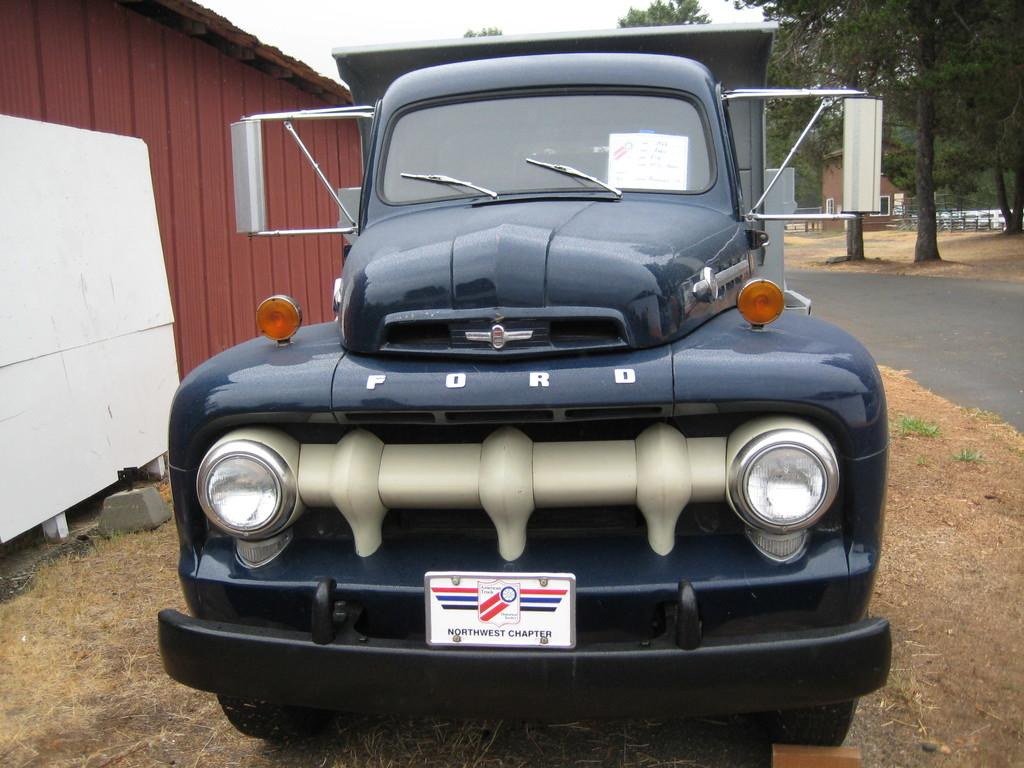What is the main subject of the image? There is a vehicle in the image. Can you describe the color of the vehicle? The vehicle is blue. What can be seen in the background of the image? There is a shed and trees in the background of the image. What is the color of the trees in the image? The trees are green. How would you describe the sky in the image? The sky is white in the image. How many tails can be seen on the vehicle in the image? There are no tails visible on the vehicle in the image. In which direction is the vehicle facing in the image? The image does not provide information about the direction the vehicle is facing. 